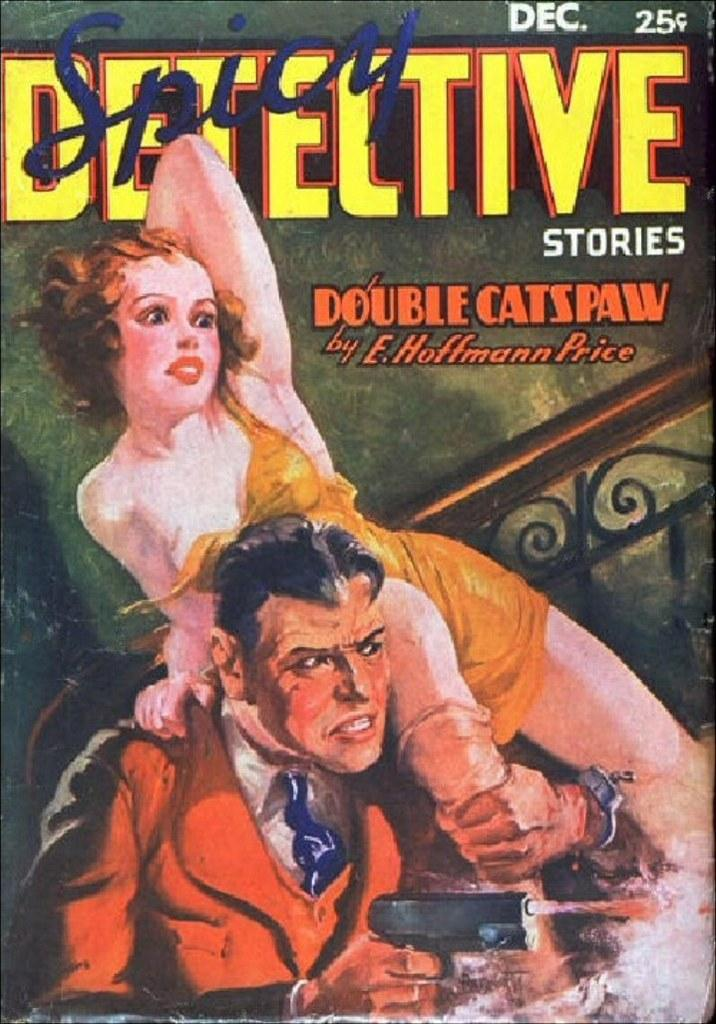<image>
Create a compact narrative representing the image presented. POster showing a man holding a gun titled Detective Stories. 